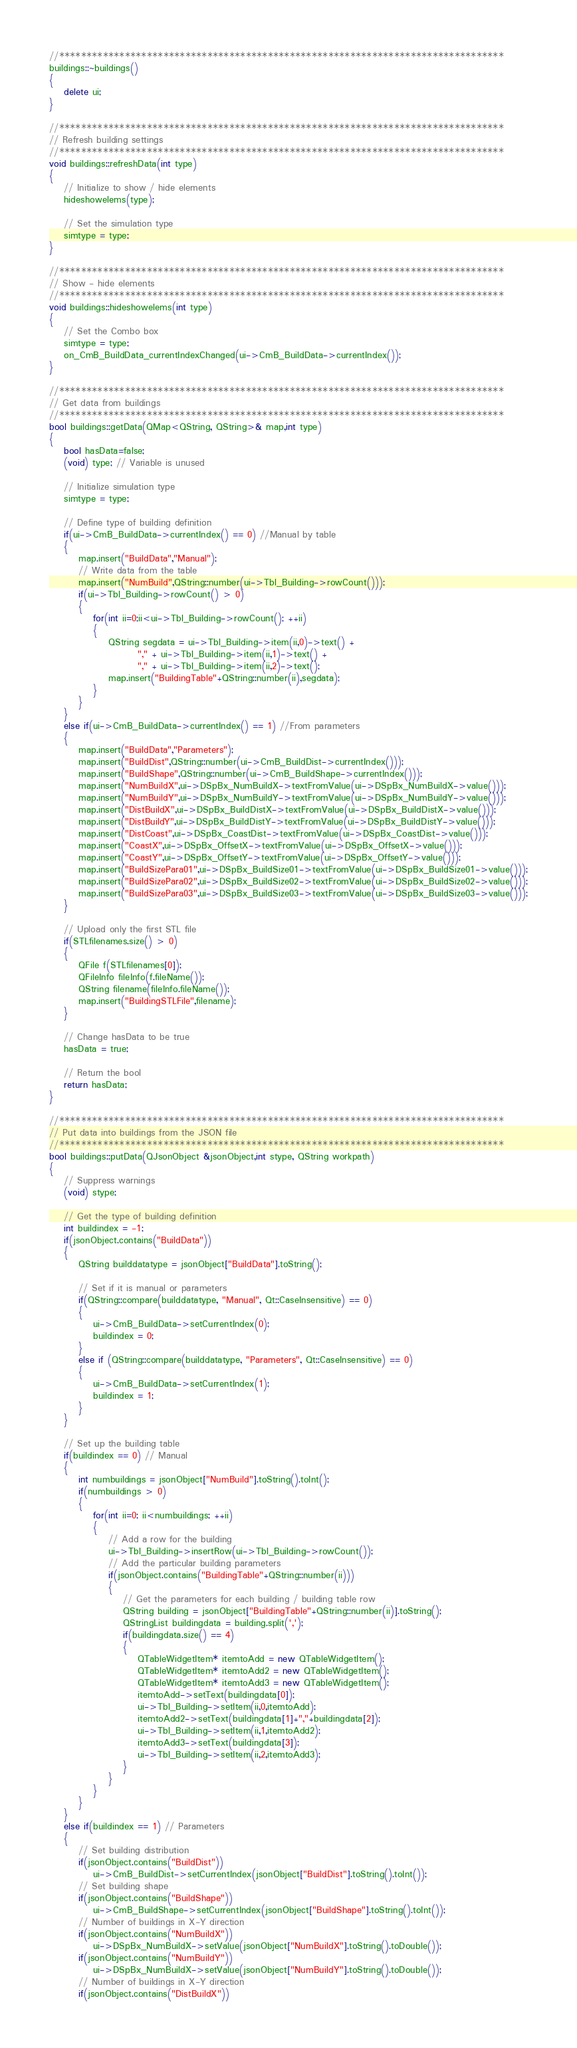<code> <loc_0><loc_0><loc_500><loc_500><_C++_>//*********************************************************************************
buildings::~buildings()
{
    delete ui;
}

//*********************************************************************************
// Refresh building settings
//*********************************************************************************
void buildings::refreshData(int type)
{
    // Initialize to show / hide elements
    hideshowelems(type);

    // Set the simulation type
    simtype = type;
}

//*********************************************************************************
// Show - hide elements
//*********************************************************************************
void buildings::hideshowelems(int type)
{
    // Set the Combo box
    simtype = type;
    on_CmB_BuildData_currentIndexChanged(ui->CmB_BuildData->currentIndex());
}

//*********************************************************************************
// Get data from buildings
//*********************************************************************************
bool buildings::getData(QMap<QString, QString>& map,int type)
{
    bool hasData=false;
    (void) type; // Variable is unused

    // Initialize simulation type
    simtype = type;

    // Define type of building definition
    if(ui->CmB_BuildData->currentIndex() == 0) //Manual by table
    {
        map.insert("BuildData","Manual");
        // Write data from the table
        map.insert("NumBuild",QString::number(ui->Tbl_Building->rowCount()));
        if(ui->Tbl_Building->rowCount() > 0)
        {
            for(int ii=0;ii<ui->Tbl_Building->rowCount(); ++ii)
            {
                QString segdata = ui->Tbl_Building->item(ii,0)->text() +
                        "," + ui->Tbl_Building->item(ii,1)->text() +
                        "," + ui->Tbl_Building->item(ii,2)->text();
                map.insert("BuildingTable"+QString::number(ii),segdata);
            }
        }
    }
    else if(ui->CmB_BuildData->currentIndex() == 1) //From parameters
    {
        map.insert("BuildData","Parameters");
        map.insert("BuildDist",QString::number(ui->CmB_BuildDist->currentIndex()));
        map.insert("BuildShape",QString::number(ui->CmB_BuildShape->currentIndex()));
        map.insert("NumBuildX",ui->DSpBx_NumBuildX->textFromValue(ui->DSpBx_NumBuildX->value()));
        map.insert("NumBuildY",ui->DSpBx_NumBuildY->textFromValue(ui->DSpBx_NumBuildY->value()));
        map.insert("DistBuildX",ui->DSpBx_BuildDistX->textFromValue(ui->DSpBx_BuildDistX->value()));
        map.insert("DistBuildY",ui->DSpBx_BuildDistY->textFromValue(ui->DSpBx_BuildDistY->value()));
        map.insert("DistCoast",ui->DSpBx_CoastDist->textFromValue(ui->DSpBx_CoastDist->value()));
        map.insert("CoastX",ui->DSpBx_OffsetX->textFromValue(ui->DSpBx_OffsetX->value()));
        map.insert("CoastY",ui->DSpBx_OffsetY->textFromValue(ui->DSpBx_OffsetY->value()));
        map.insert("BuildSizePara01",ui->DSpBx_BuildSize01->textFromValue(ui->DSpBx_BuildSize01->value()));
        map.insert("BuildSizePara02",ui->DSpBx_BuildSize02->textFromValue(ui->DSpBx_BuildSize02->value()));
        map.insert("BuildSizePara03",ui->DSpBx_BuildSize03->textFromValue(ui->DSpBx_BuildSize03->value()));
    }

    // Upload only the first STL file
    if(STLfilenames.size() > 0)
    {
        QFile f(STLfilenames[0]);
        QFileInfo fileInfo(f.fileName());
        QString filename(fileInfo.fileName());
        map.insert("BuildingSTLFile",filename);
    }

    // Change hasData to be true
    hasData = true;

    // Return the bool
    return hasData;
}

//*********************************************************************************
// Put data into buildings from the JSON file
//*********************************************************************************
bool buildings::putData(QJsonObject &jsonObject,int stype, QString workpath)
{
    // Suppress warnings
    (void) stype;

    // Get the type of building definition
    int buildindex = -1;
    if(jsonObject.contains("BuildData"))
    {
        QString builddatatype = jsonObject["BuildData"].toString();

        // Set if it is manual or parameters
        if(QString::compare(builddatatype, "Manual", Qt::CaseInsensitive) == 0)
        {
            ui->CmB_BuildData->setCurrentIndex(0);
            buildindex = 0;
        }
        else if (QString::compare(builddatatype, "Parameters", Qt::CaseInsensitive) == 0)
        {
            ui->CmB_BuildData->setCurrentIndex(1);
            buildindex = 1;
        }
    }

    // Set up the building table
    if(buildindex == 0) // Manual
    {
        int numbuildings = jsonObject["NumBuild"].toString().toInt();
        if(numbuildings > 0)
        {
            for(int ii=0; ii<numbuildings; ++ii)
            {
                // Add a row for the building
                ui->Tbl_Building->insertRow(ui->Tbl_Building->rowCount());
                // Add the particular building parameters
                if(jsonObject.contains("BuildingTable"+QString::number(ii)))
                {
                    // Get the parameters for each building / building table row
                    QString building = jsonObject["BuildingTable"+QString::number(ii)].toString();
                    QStringList buildingdata = building.split(',');
                    if(buildingdata.size() == 4)
                    {
                        QTableWidgetItem* itemtoAdd = new QTableWidgetItem();
                        QTableWidgetItem* itemtoAdd2 = new QTableWidgetItem();
                        QTableWidgetItem* itemtoAdd3 = new QTableWidgetItem();
                        itemtoAdd->setText(buildingdata[0]);
                        ui->Tbl_Building->setItem(ii,0,itemtoAdd);
                        itemtoAdd2->setText(buildingdata[1]+","+buildingdata[2]);
                        ui->Tbl_Building->setItem(ii,1,itemtoAdd2);
                        itemtoAdd3->setText(buildingdata[3]);
                        ui->Tbl_Building->setItem(ii,2,itemtoAdd3);
                    }
                }
            }
        }
    }
    else if(buildindex == 1) // Parameters
    {
        // Set building distribution
        if(jsonObject.contains("BuildDist"))
            ui->CmB_BuildDist->setCurrentIndex(jsonObject["BuildDist"].toString().toInt());
        // Set building shape
        if(jsonObject.contains("BuildShape"))
            ui->CmB_BuildShape->setCurrentIndex(jsonObject["BuildShape"].toString().toInt());
        // Number of buildings in X-Y direction
        if(jsonObject.contains("NumBuildX"))
            ui->DSpBx_NumBuildX->setValue(jsonObject["NumBuildX"].toString().toDouble());
        if(jsonObject.contains("NumBuildY"))
            ui->DSpBx_NumBuildX->setValue(jsonObject["NumBuildY"].toString().toDouble());
        // Number of buildings in X-Y direction
        if(jsonObject.contains("DistBuildX"))</code> 